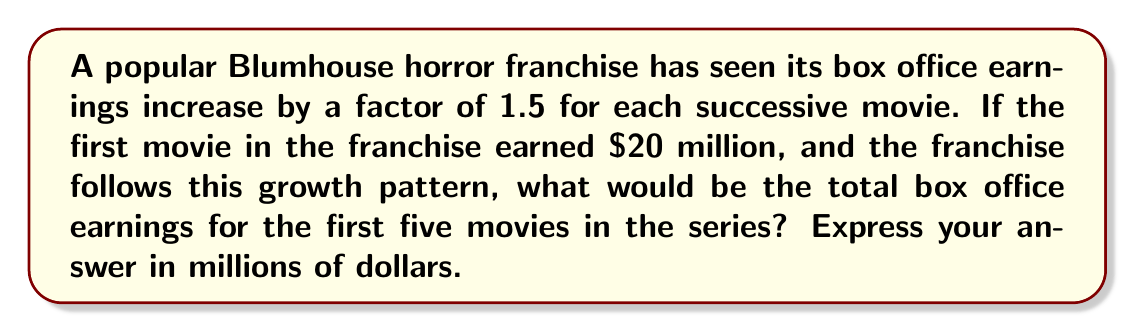Provide a solution to this math problem. Let's break this down step-by-step:

1) First, let's calculate the earnings for each movie:

   Movie 1: $20 million
   Movie 2: $20 * 1.5 = $30 million
   Movie 3: $30 * 1.5 = $45 million
   Movie 4: $45 * 1.5 = $67.5 million
   Movie 5: $67.5 * 1.5 = $101.25 million

2) Now, we need to sum up these earnings:

   $$\text{Total} = 20 + 30 + 45 + 67.5 + 101.25$$

3) Let's add these numbers:

   $$\text{Total} = 263.75$$

Therefore, the total box office earnings for the first five movies in the franchise would be $263.75 million.
Answer: $263.75 million 